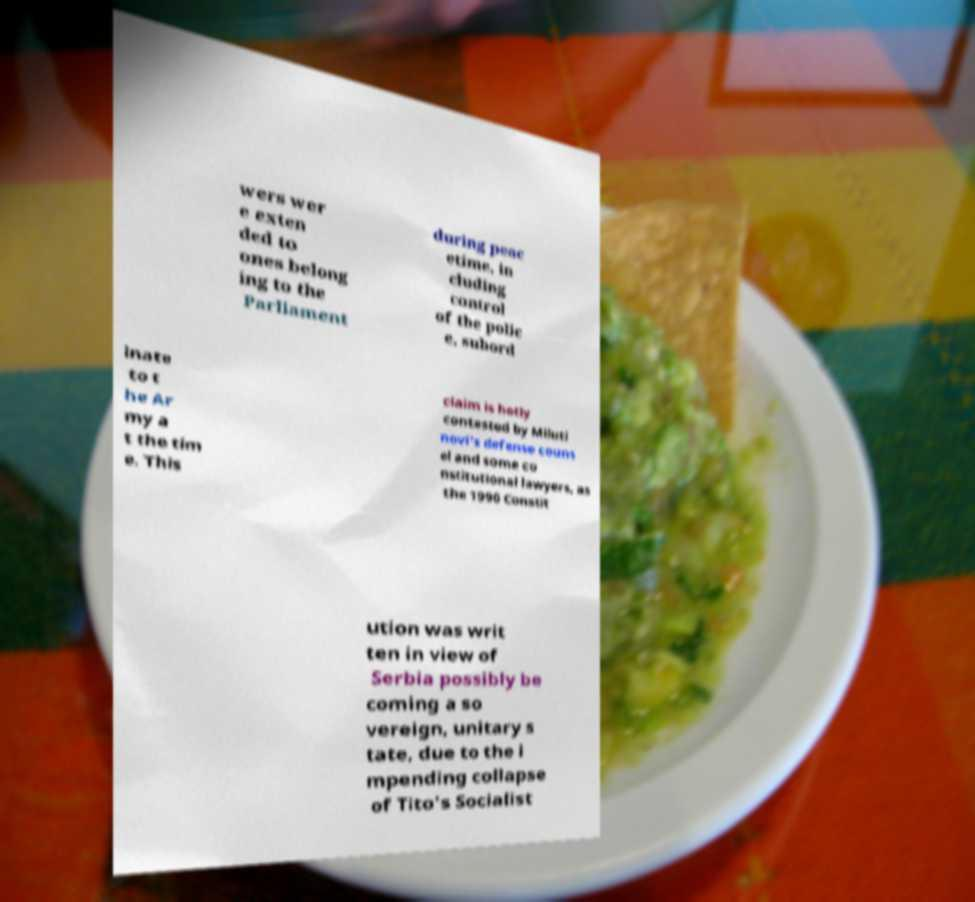What messages or text are displayed in this image? I need them in a readable, typed format. wers wer e exten ded to ones belong ing to the Parliament during peac etime, in cluding control of the polic e, subord inate to t he Ar my a t the tim e. This claim is hotly contested by Miluti novi's defense couns el and some co nstitutional lawyers, as the 1990 Constit ution was writ ten in view of Serbia possibly be coming a so vereign, unitary s tate, due to the i mpending collapse of Tito's Socialist 